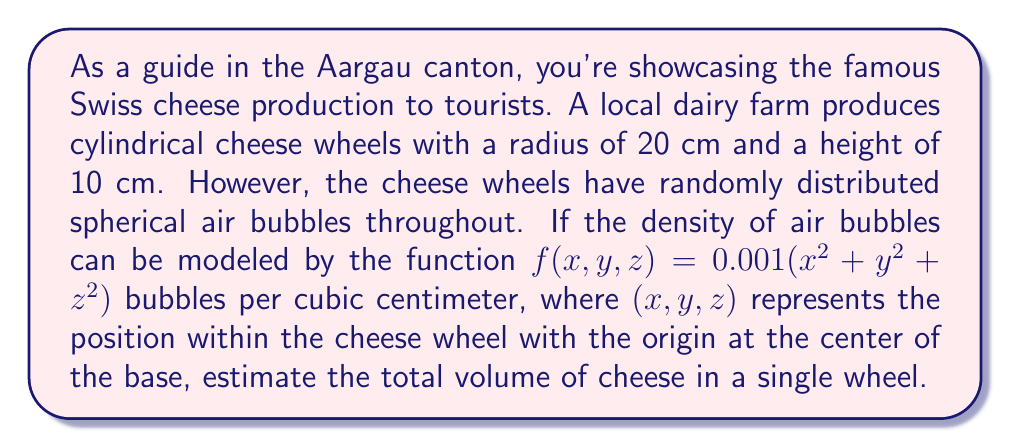Provide a solution to this math problem. To solve this problem, we need to use multivariable calculus, specifically triple integrals. Let's approach this step-by-step:

1) First, we need to set up the triple integral for the total volume of the cheese wheel without considering the air bubbles:

   $$V_{total} = \pi r^2 h = \pi (20\text{ cm})^2 (10\text{ cm}) = 4000\pi \text{ cm}^3$$

2) Now, we need to calculate the volume of the air bubbles. The density function gives us the number of bubbles per cubic centimeter, but we need to convert this to a volume. Let's assume each bubble has a volume of 0.1 cm³.

3) To find the total volume of air bubbles, we need to integrate the density function over the entire cheese wheel and multiply by the volume per bubble:

   $$V_{bubbles} = 0.1 \iiint_V f(x,y,z) \, dV$$

4) Given the cylindrical shape of the cheese wheel, it's best to use cylindrical coordinates:
   $x = r\cos\theta$, $y = r\sin\theta$, $z = z$
   $0 \leq r \leq 20$, $0 \leq \theta \leq 2\pi$, $0 \leq z \leq 10$

5) The density function in cylindrical coordinates becomes:
   $f(r,\theta,z) = 0.001(r^2 + z^2)$

6) Now we can set up our triple integral:

   $$V_{bubbles} = 0.1 \int_0^{10} \int_0^{2\pi} \int_0^{20} 0.001(r^2 + z^2) \, r \, dr \, d\theta \, dz$$

7) Simplifying:

   $$V_{bubbles} = 0.0001 \int_0^{10} \int_0^{2\pi} \int_0^{20} (r^3 + rz^2) \, dr \, d\theta \, dz$$

8) Integrating with respect to r:

   $$V_{bubbles} = 0.0001 \int_0^{10} \int_0^{2\pi} [\frac{r^4}{4} + \frac{r^2z^2}{2}]_0^{20} \, d\theta \, dz$$
   $$= 0.0001 \int_0^{10} \int_0^{2\pi} (40000 + 200z^2) \, d\theta \, dz$$

9) Integrating with respect to θ:

   $$V_{bubbles} = 0.0002\pi \int_0^{10} (40000 + 200z^2) \, dz$$

10) Finally, integrating with respect to z:

    $$V_{bubbles} = 0.0002\pi [40000z + \frac{200z^3}{3}]_0^{10}$$
    $$= 0.0002\pi (400000 + \frac{200000}{3}) = \frac{1600\pi}{3} \text{ cm}^3$$

11) The actual volume of cheese is the total volume minus the volume of air bubbles:

    $$V_{cheese} = V_{total} - V_{bubbles} = 4000\pi - \frac{1600\pi}{3} = \frac{10400\pi}{3} \text{ cm}^3$$
Answer: The estimated volume of cheese in a single wheel is $\frac{10400\pi}{3} \approx 10888.41 \text{ cm}^3$. 